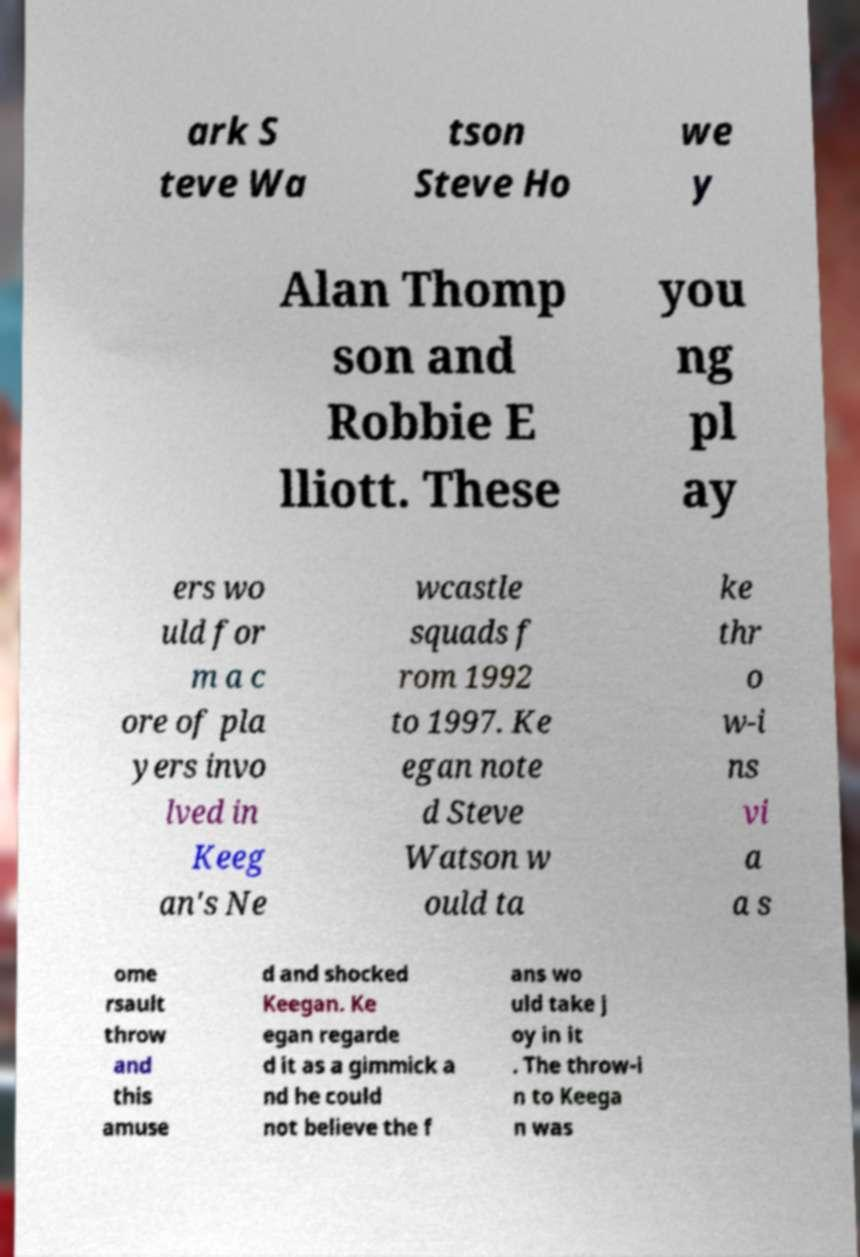For documentation purposes, I need the text within this image transcribed. Could you provide that? ark S teve Wa tson Steve Ho we y Alan Thomp son and Robbie E lliott. These you ng pl ay ers wo uld for m a c ore of pla yers invo lved in Keeg an's Ne wcastle squads f rom 1992 to 1997. Ke egan note d Steve Watson w ould ta ke thr o w-i ns vi a a s ome rsault throw and this amuse d and shocked Keegan. Ke egan regarde d it as a gimmick a nd he could not believe the f ans wo uld take j oy in it . The throw-i n to Keega n was 